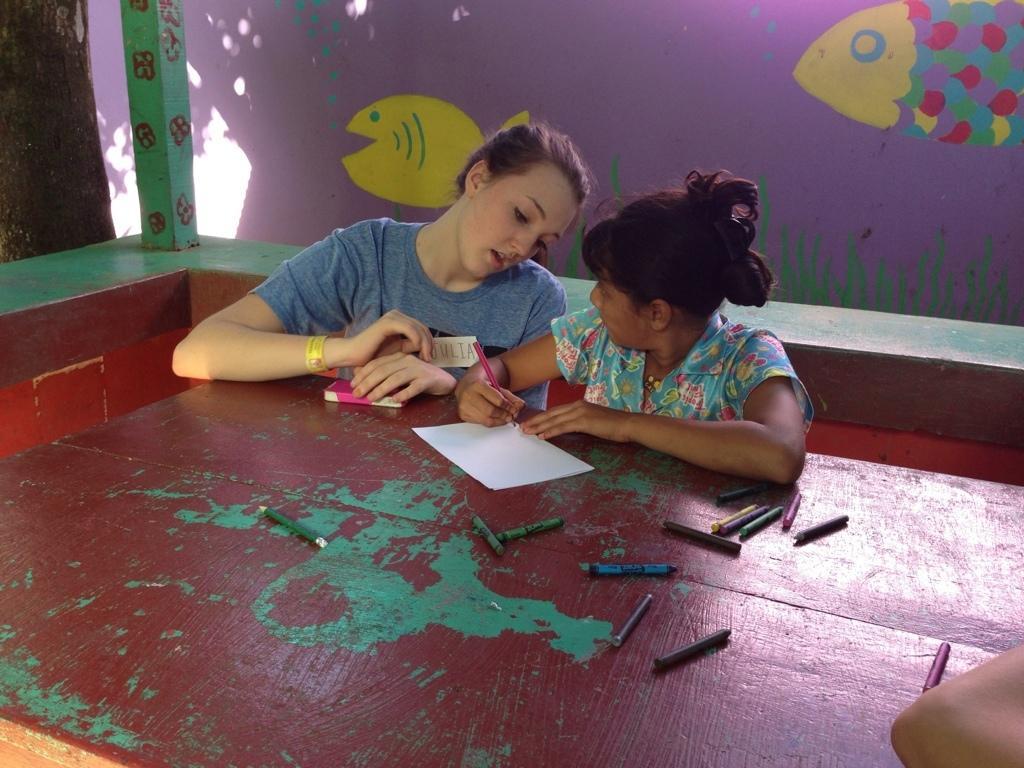Could you give a brief overview of what you see in this image? In this image we can see two persons wearing ash and multi colors T-shirts sitting on bench doing sketch, there are some sketch pens, paper on the table and in the background of the image there is a wall and there are some fish paintings to it. 